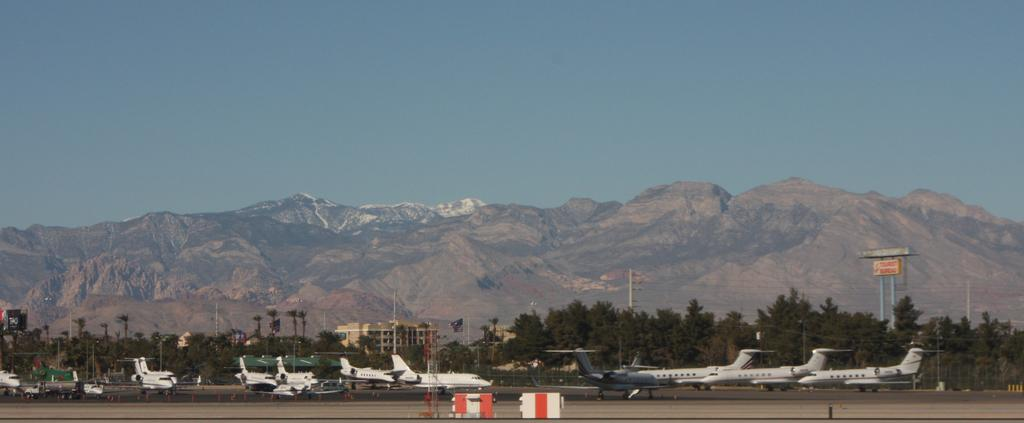What unusual sight can be seen on the road in the image? There are airplanes on the road in the image. What might be used to control traffic or block off the road in the image? Barricades are present in the image. What object can be seen standing upright in the image? There is a pole in the image. What type of natural environment is visible in the background of the image? A mountain is visible in the background. What is the color of the sky in the image? The sky is blue in color. How many chairs can be seen stacked on the table in the image? There are no chairs or tables present in the image. What type of stem is growing from the pole in the image? There is no stem growing from the pole in the image. 